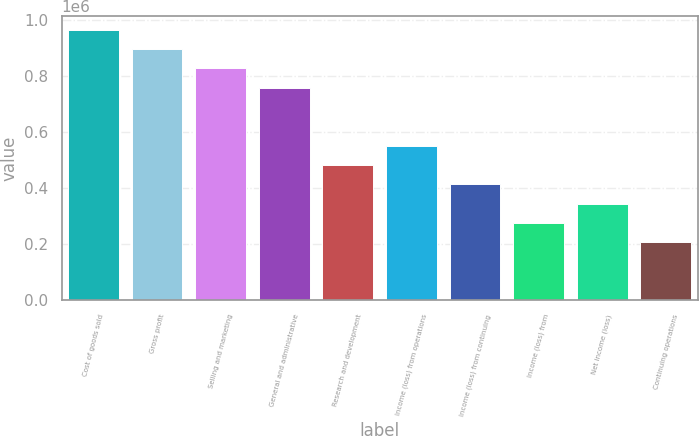Convert chart. <chart><loc_0><loc_0><loc_500><loc_500><bar_chart><fcel>Cost of goods sold<fcel>Gross profit<fcel>Selling and marketing<fcel>General and administrative<fcel>Research and development<fcel>Income (loss) from operations<fcel>Income (loss) from continuing<fcel>Income (loss) from<fcel>Net income (loss)<fcel>Continuing operations<nl><fcel>965133<fcel>896195<fcel>827257<fcel>758319<fcel>482567<fcel>551505<fcel>413629<fcel>275752<fcel>344691<fcel>206814<nl></chart> 